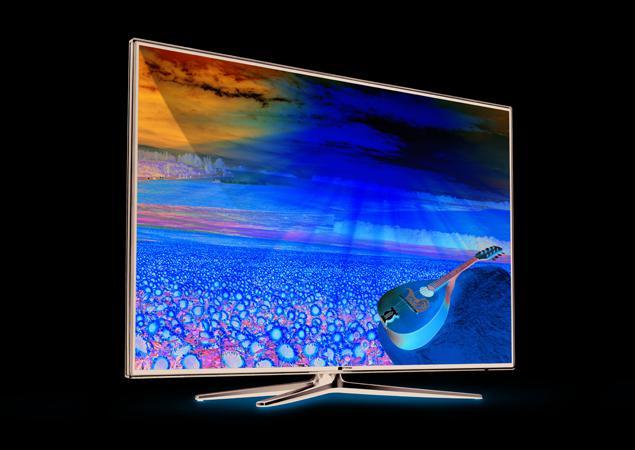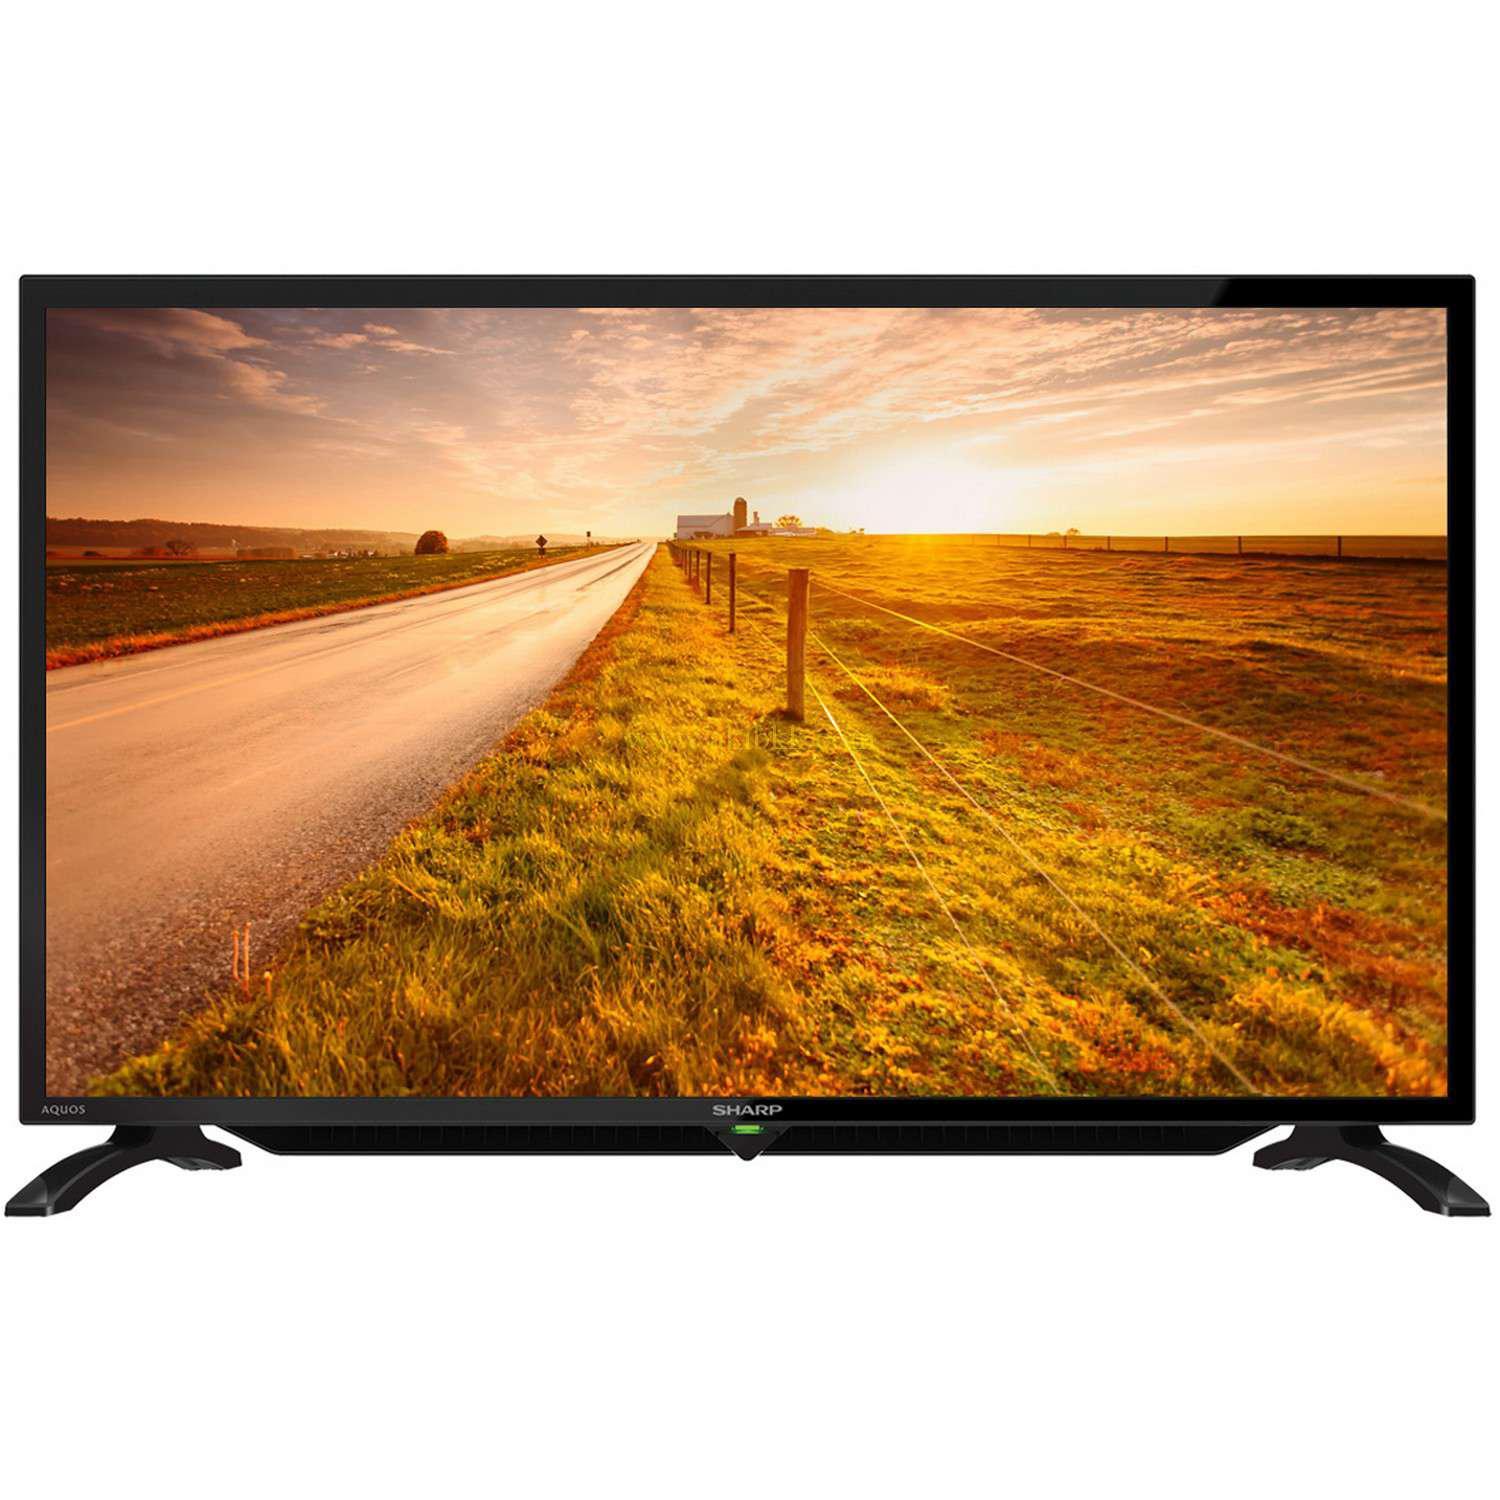The first image is the image on the left, the second image is the image on the right. Evaluate the accuracy of this statement regarding the images: "Each television shows a wordless nature scene.". Is it true? Answer yes or no. Yes. 